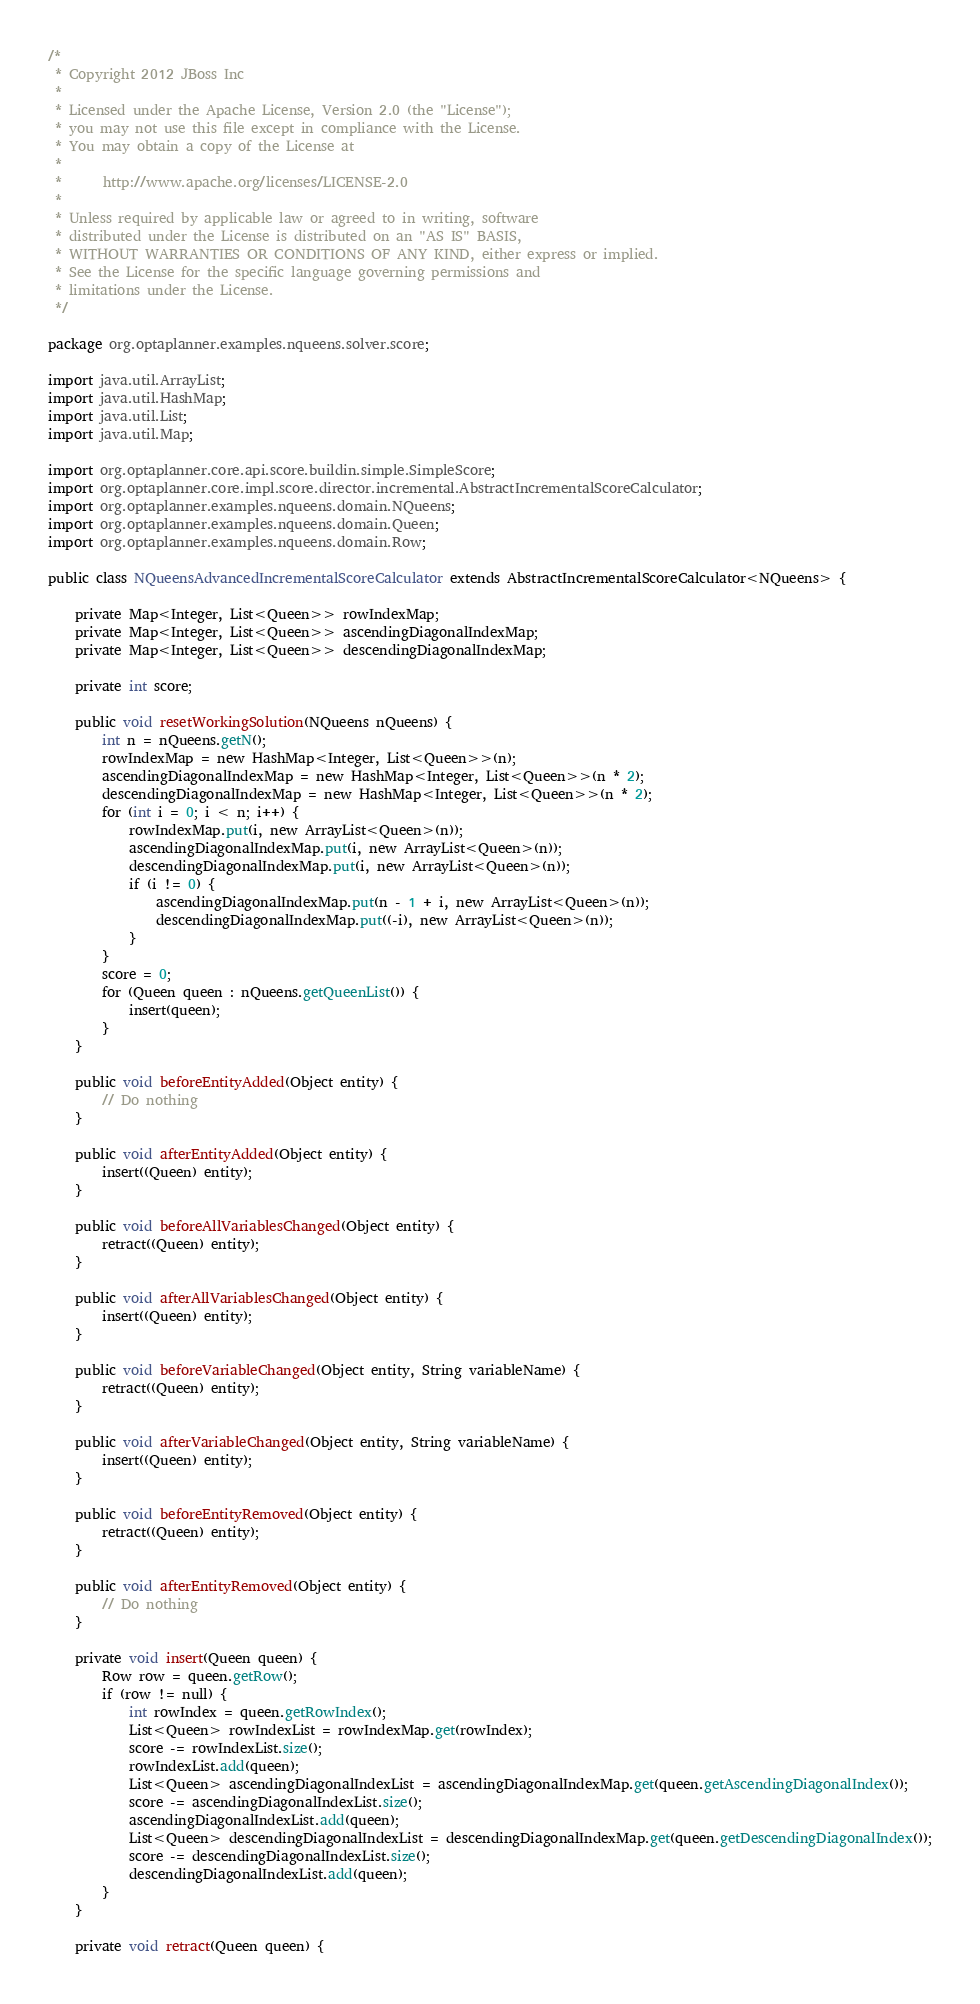Convert code to text. <code><loc_0><loc_0><loc_500><loc_500><_Java_>/*
 * Copyright 2012 JBoss Inc
 *
 * Licensed under the Apache License, Version 2.0 (the "License");
 * you may not use this file except in compliance with the License.
 * You may obtain a copy of the License at
 *
 *      http://www.apache.org/licenses/LICENSE-2.0
 *
 * Unless required by applicable law or agreed to in writing, software
 * distributed under the License is distributed on an "AS IS" BASIS,
 * WITHOUT WARRANTIES OR CONDITIONS OF ANY KIND, either express or implied.
 * See the License for the specific language governing permissions and
 * limitations under the License.
 */

package org.optaplanner.examples.nqueens.solver.score;

import java.util.ArrayList;
import java.util.HashMap;
import java.util.List;
import java.util.Map;

import org.optaplanner.core.api.score.buildin.simple.SimpleScore;
import org.optaplanner.core.impl.score.director.incremental.AbstractIncrementalScoreCalculator;
import org.optaplanner.examples.nqueens.domain.NQueens;
import org.optaplanner.examples.nqueens.domain.Queen;
import org.optaplanner.examples.nqueens.domain.Row;

public class NQueensAdvancedIncrementalScoreCalculator extends AbstractIncrementalScoreCalculator<NQueens> {

    private Map<Integer, List<Queen>> rowIndexMap;
    private Map<Integer, List<Queen>> ascendingDiagonalIndexMap;
    private Map<Integer, List<Queen>> descendingDiagonalIndexMap;

    private int score;

    public void resetWorkingSolution(NQueens nQueens) {
        int n = nQueens.getN();
        rowIndexMap = new HashMap<Integer, List<Queen>>(n);
        ascendingDiagonalIndexMap = new HashMap<Integer, List<Queen>>(n * 2);
        descendingDiagonalIndexMap = new HashMap<Integer, List<Queen>>(n * 2);
        for (int i = 0; i < n; i++) {
            rowIndexMap.put(i, new ArrayList<Queen>(n));
            ascendingDiagonalIndexMap.put(i, new ArrayList<Queen>(n));
            descendingDiagonalIndexMap.put(i, new ArrayList<Queen>(n));
            if (i != 0) {
                ascendingDiagonalIndexMap.put(n - 1 + i, new ArrayList<Queen>(n));
                descendingDiagonalIndexMap.put((-i), new ArrayList<Queen>(n));
            }
        }
        score = 0;
        for (Queen queen : nQueens.getQueenList()) {
            insert(queen);
        }
    }

    public void beforeEntityAdded(Object entity) {
        // Do nothing
    }

    public void afterEntityAdded(Object entity) {
        insert((Queen) entity);
    }

    public void beforeAllVariablesChanged(Object entity) {
        retract((Queen) entity);
    }

    public void afterAllVariablesChanged(Object entity) {
        insert((Queen) entity);
    }

    public void beforeVariableChanged(Object entity, String variableName) {
        retract((Queen) entity);
    }

    public void afterVariableChanged(Object entity, String variableName) {
        insert((Queen) entity);
    }

    public void beforeEntityRemoved(Object entity) {
        retract((Queen) entity);
    }

    public void afterEntityRemoved(Object entity) {
        // Do nothing
    }

    private void insert(Queen queen) {
        Row row = queen.getRow();
        if (row != null) {
            int rowIndex = queen.getRowIndex();
            List<Queen> rowIndexList = rowIndexMap.get(rowIndex);
            score -= rowIndexList.size();
            rowIndexList.add(queen);
            List<Queen> ascendingDiagonalIndexList = ascendingDiagonalIndexMap.get(queen.getAscendingDiagonalIndex());
            score -= ascendingDiagonalIndexList.size();
            ascendingDiagonalIndexList.add(queen);
            List<Queen> descendingDiagonalIndexList = descendingDiagonalIndexMap.get(queen.getDescendingDiagonalIndex());
            score -= descendingDiagonalIndexList.size();
            descendingDiagonalIndexList.add(queen);
        }
    }

    private void retract(Queen queen) {</code> 